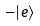<formula> <loc_0><loc_0><loc_500><loc_500>- | e \rangle</formula> 